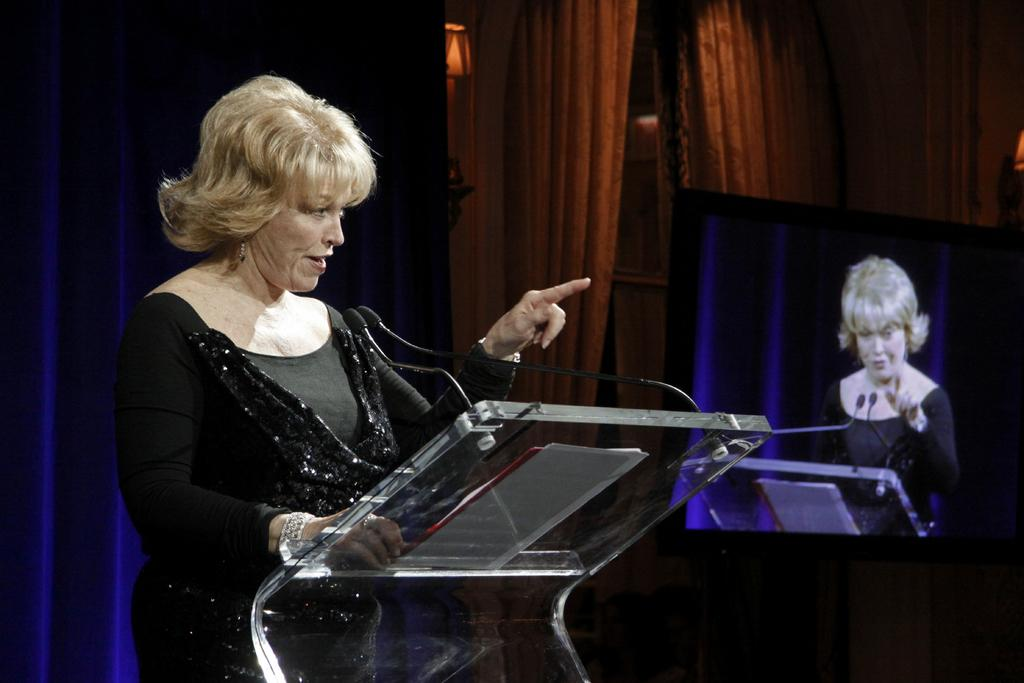Who is the main subject in the image? There is a woman in the image. What is the woman wearing? The woman is wearing a black dress. What is the woman doing in the image? The woman is standing and speaking in front of a mic. What can be seen in the right corner of the image? There is a television in the right corner of the image. What is displayed on the television? The television is displaying a picture. What type of regret can be seen on the woman's face in the image? There is no indication of regret on the woman's face in the image. 